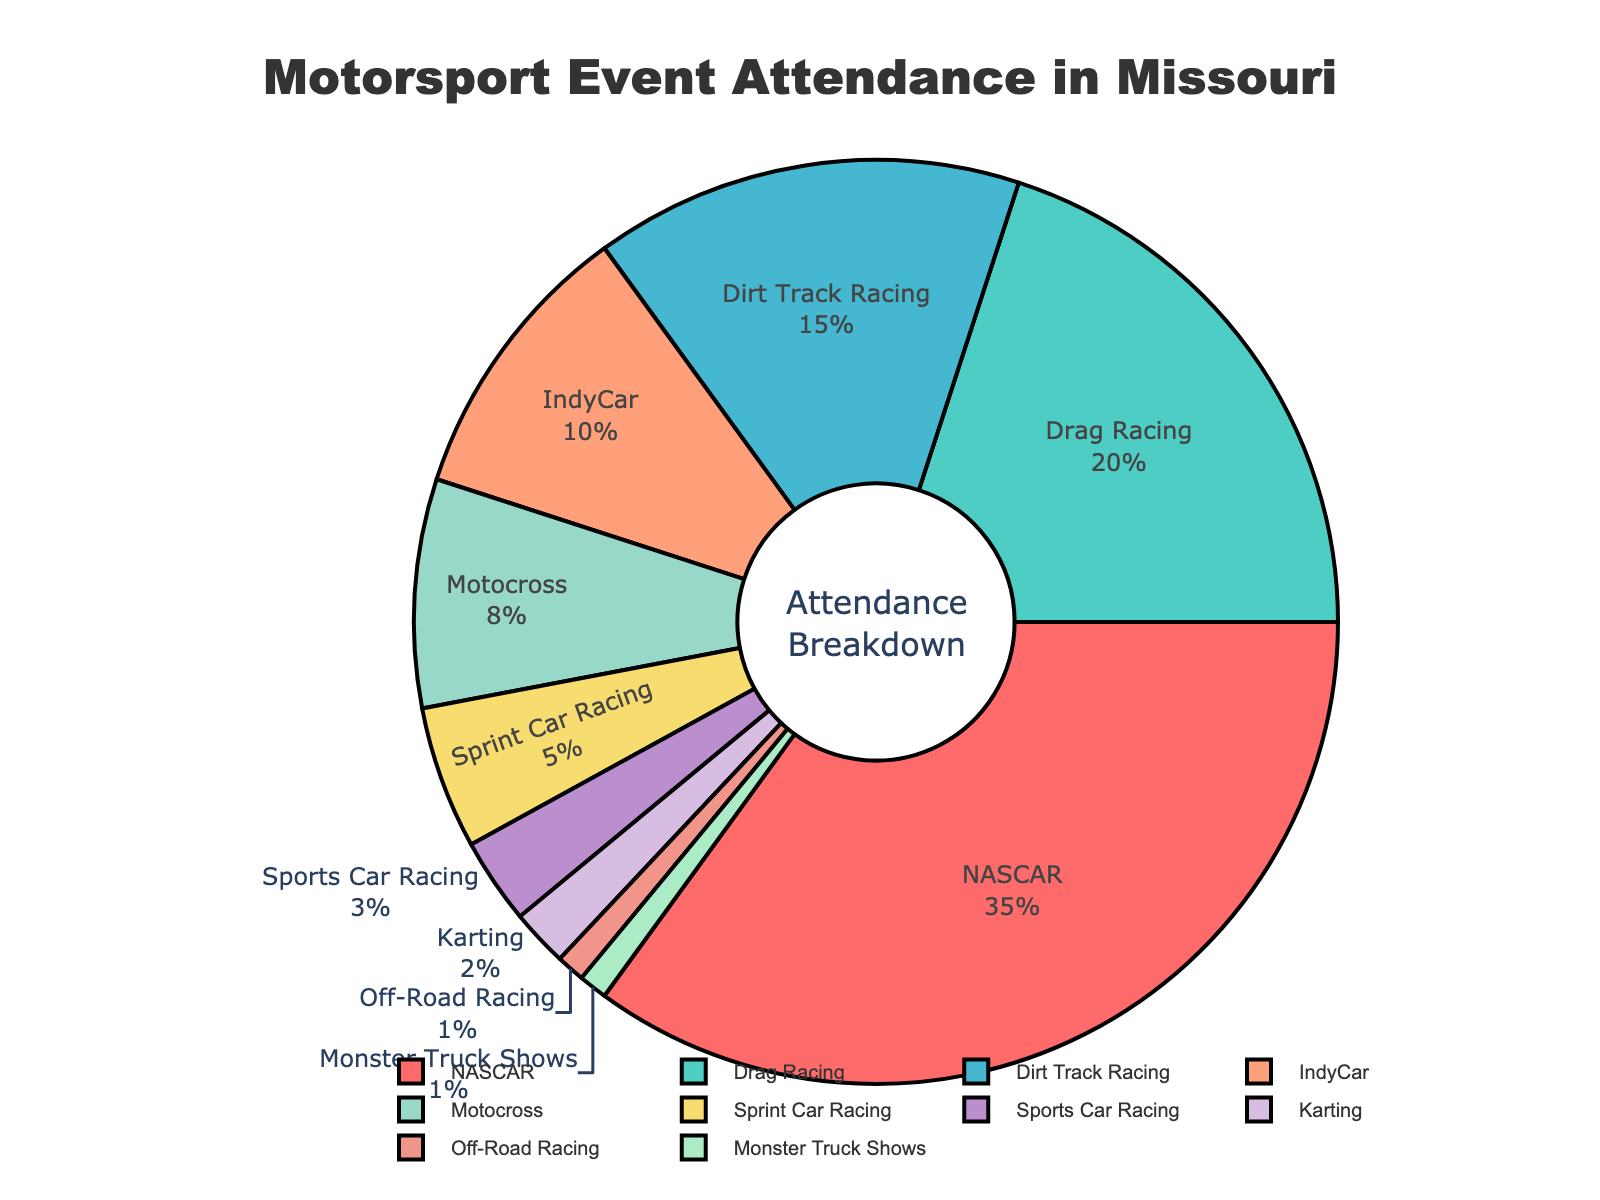What is the race type with the highest attendance percentage? The largest slice of the pie chart represents the race type with the highest attendance. Here, the NASCAR slice is the largest with 35%.
Answer: NASCAR Which race types have an attendance percentage that is greater than 10%? To answer, identify all slices in the pie chart whose labels have more than 10% attendance. These race types are NASCAR (35%), Drag Racing (20%), and Dirt Track Racing (15%).
Answer: NASCAR, Drag Racing, Dirt Track Racing How does the attendance percentage for IndyCar compare to that of Motocross? Compare the sizes of the slices labeled IndyCar and Motocross. IndyCar has 10% and Motocross has 8%, so IndyCar has a higher attendance percentage.
Answer: IndyCar has a higher attendance percentage What is the combined attendance percentage for Sprint Car Racing and Sports Car Racing? Add the attendance percentages of Sprint Car Racing (5%) and Sports Car Racing (3%) to find the total. 5% + 3% = 8%.
Answer: 8% What percentage of attendees for Missouri motorsport events are drawn to the top three race types? Sum the attendance percentages for the top three race types: NASCAR (35%), Drag Racing (20%), and Dirt Track Racing (15%). The total is 35% + 20% + 15% = 70%.
Answer: 70% Which race type has the smallest attendance percentage, and what is it? Identify the smallest slice in the pie chart. Both Off-Road Racing and Monster Truck Shows have the smallest slices at 1% each.
Answer: Off-Road Racing, Monster Truck Shows Are there more attendees for Drag Racing than for Motocross and Karting combined? Sum the attendance percentages for Motocross (8%) and Karting (2%). Then compare this sum (8% + 2% = 10%) to Drag Racing's attendance (20%). Drag Racing has a higher percentage than the sum of Motocross and Karting.
Answer: Yes Is the attendance percentage for Dirt Track Racing closer to the attendance percentage for Motocross or IndyCar? Determine the differences: Dirt Track Racing (15%) - Motocross (8%) = 7%, and Dirt Track Racing (15%) - IndyCar (10%) = 5%. The difference is smaller for IndyCar.
Answer: IndyCar 